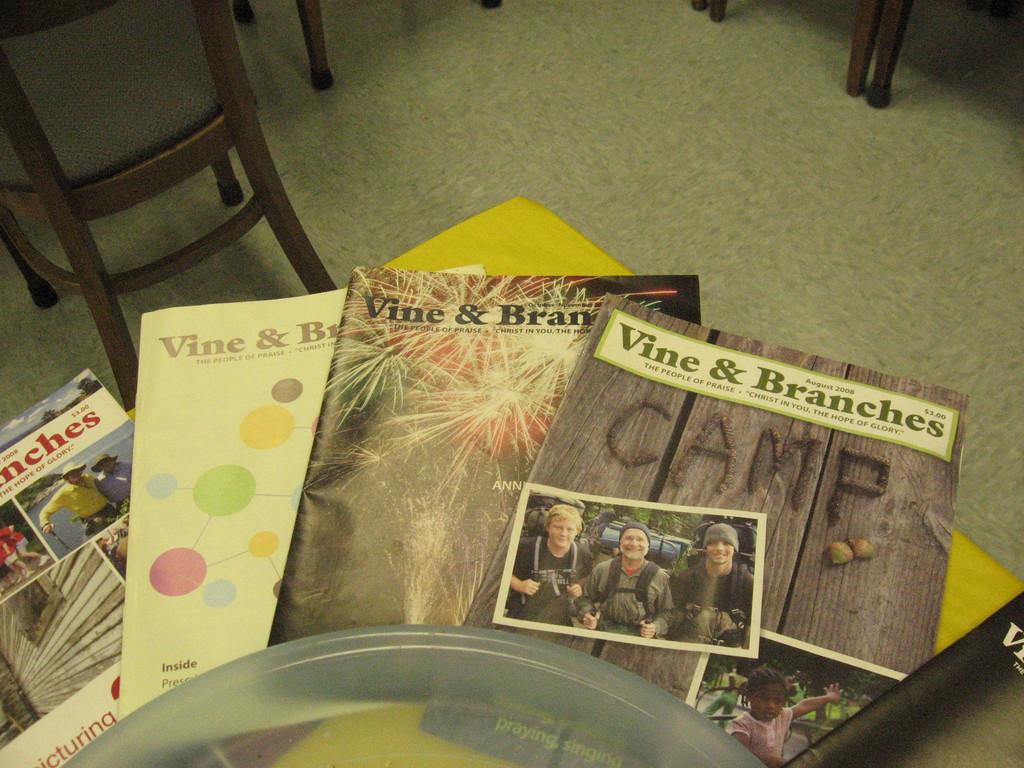<image>
Create a compact narrative representing the image presented. Several magazines sit on a table, one says the word CAMP on it. 